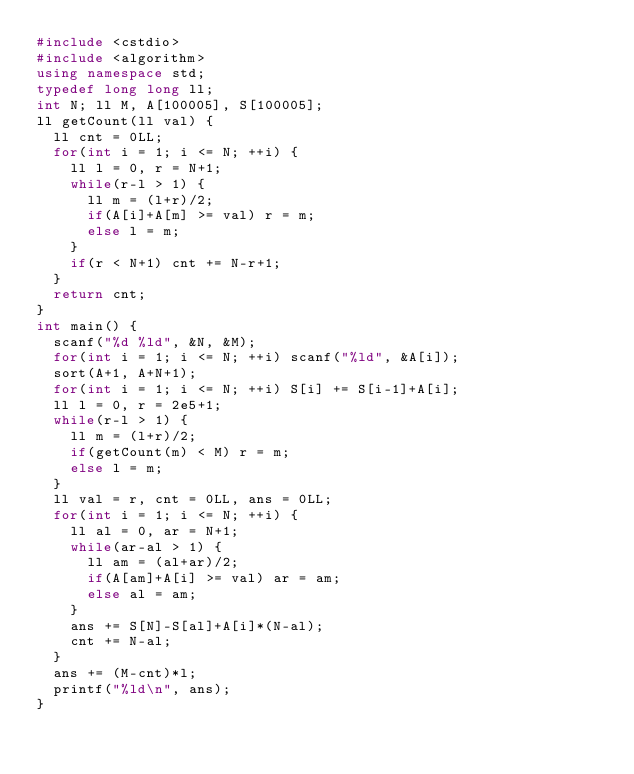<code> <loc_0><loc_0><loc_500><loc_500><_C++_>#include <cstdio>
#include <algorithm>
using namespace std;
typedef long long ll;
int N; ll M, A[100005], S[100005];
ll getCount(ll val) {
  ll cnt = 0LL;
  for(int i = 1; i <= N; ++i) {
    ll l = 0, r = N+1;
    while(r-l > 1) {
      ll m = (l+r)/2;
      if(A[i]+A[m] >= val) r = m;
      else l = m;
    }
    if(r < N+1) cnt += N-r+1;
  }
  return cnt;
}
int main() {
  scanf("%d %ld", &N, &M);
  for(int i = 1; i <= N; ++i) scanf("%ld", &A[i]);
  sort(A+1, A+N+1);
  for(int i = 1; i <= N; ++i) S[i] += S[i-1]+A[i];
  ll l = 0, r = 2e5+1;
  while(r-l > 1) {
    ll m = (l+r)/2;
    if(getCount(m) < M) r = m;
    else l = m;
  }
  ll val = r, cnt = 0LL, ans = 0LL;
  for(int i = 1; i <= N; ++i) {
    ll al = 0, ar = N+1;
    while(ar-al > 1) {
      ll am = (al+ar)/2;
      if(A[am]+A[i] >= val) ar = am;
      else al = am;
    }
    ans += S[N]-S[al]+A[i]*(N-al);
    cnt += N-al;
  }
  ans += (M-cnt)*l;
  printf("%ld\n", ans);
}</code> 